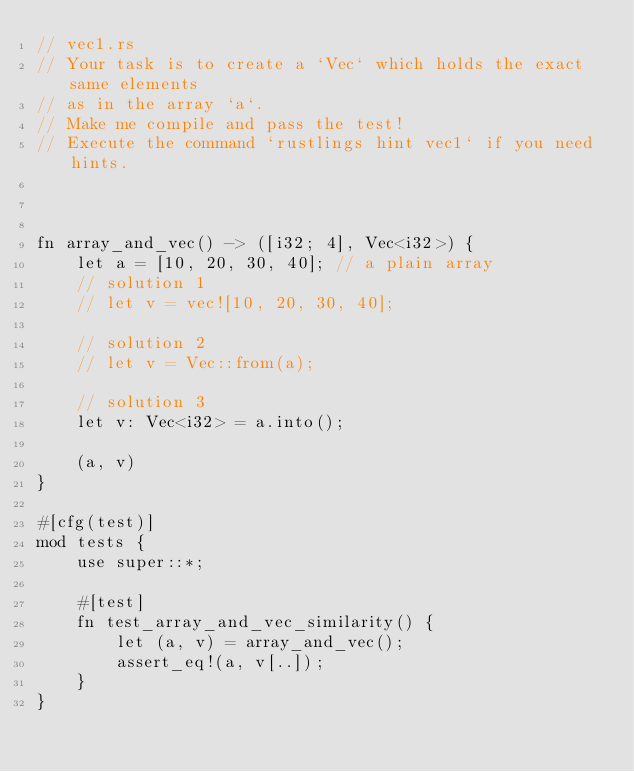Convert code to text. <code><loc_0><loc_0><loc_500><loc_500><_Rust_>// vec1.rs
// Your task is to create a `Vec` which holds the exact same elements
// as in the array `a`.
// Make me compile and pass the test!
// Execute the command `rustlings hint vec1` if you need hints.



fn array_and_vec() -> ([i32; 4], Vec<i32>) {
    let a = [10, 20, 30, 40]; // a plain array
    // solution 1
    // let v = vec![10, 20, 30, 40];

    // solution 2
    // let v = Vec::from(a);

    // solution 3
    let v: Vec<i32> = a.into();

    (a, v)
}

#[cfg(test)]
mod tests {
    use super::*;

    #[test]
    fn test_array_and_vec_similarity() {
        let (a, v) = array_and_vec();
        assert_eq!(a, v[..]);
    }
}
</code> 